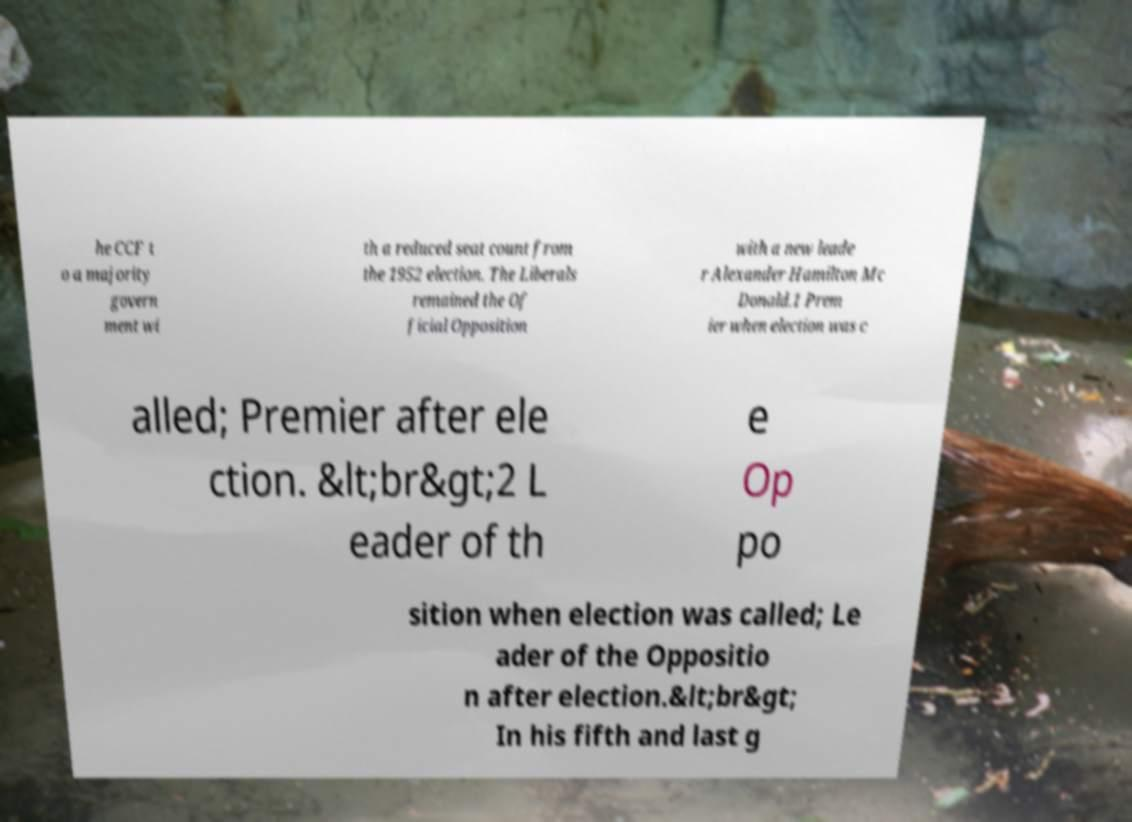Can you read and provide the text displayed in the image?This photo seems to have some interesting text. Can you extract and type it out for me? he CCF t o a majority govern ment wi th a reduced seat count from the 1952 election. The Liberals remained the Of ficial Opposition with a new leade r Alexander Hamilton Mc Donald.1 Prem ier when election was c alled; Premier after ele ction. &lt;br&gt;2 L eader of th e Op po sition when election was called; Le ader of the Oppositio n after election.&lt;br&gt; In his fifth and last g 